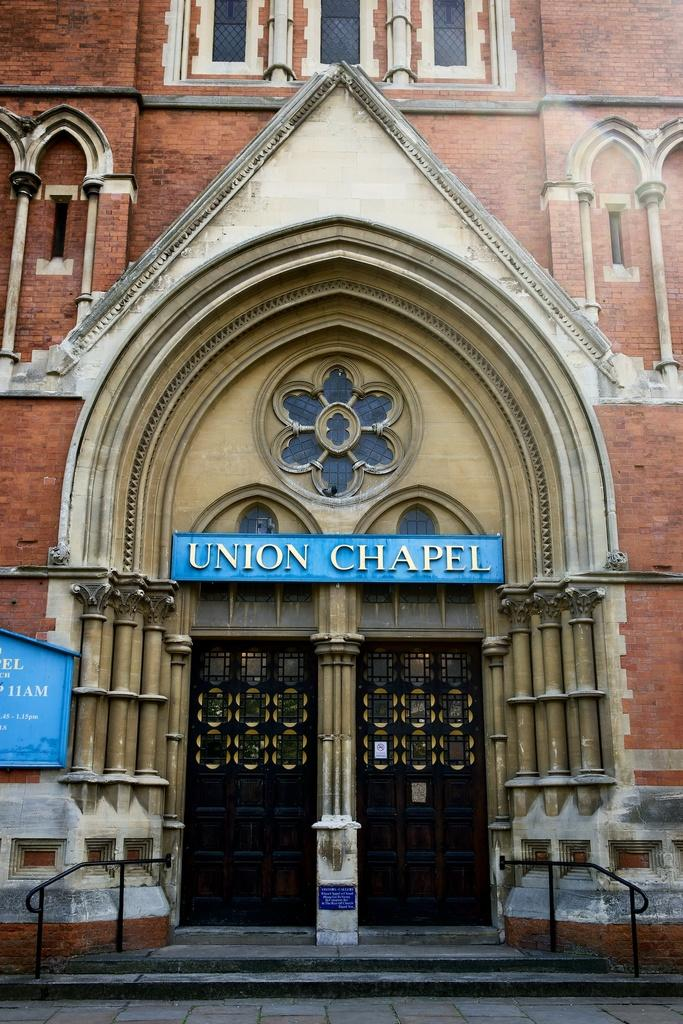What is the main subject of the image? The image depicts a famous church in London. What architectural feature can be seen on the walls of the church? The church has many windows on its walls. How many doors are at the entrance of the church? There are two doors at the entrance of the church. What type of fan is hanging from the ceiling inside the church? There is no fan visible in the image; it depicts the exterior of the church. Are there any mittens or gloves visible on the people entering the church? There are no people or their belongings visible in the image, only the church itself. 